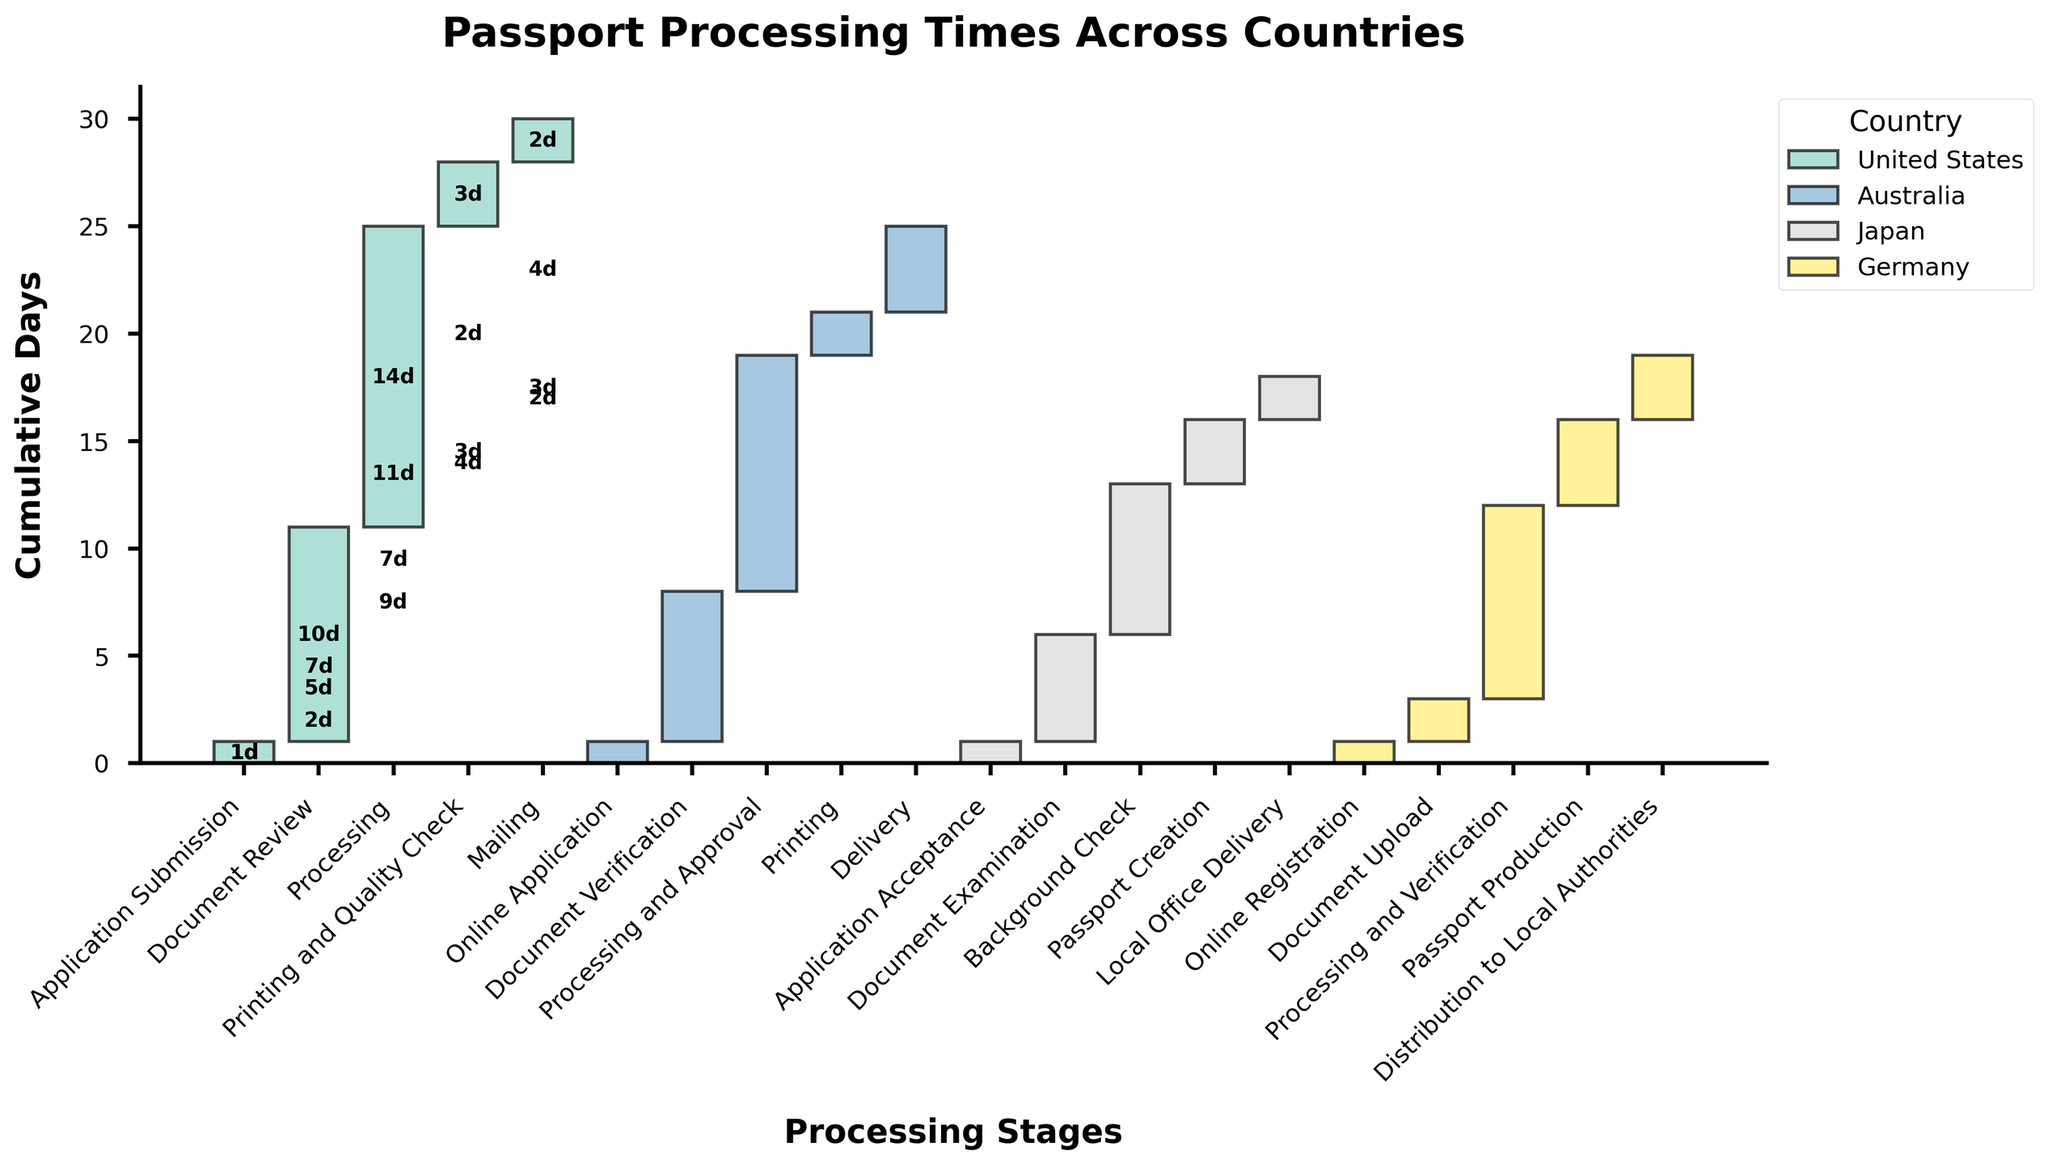What's the title of the figure? The title is located at the top of the figure, prominently displayed in larger font.
Answer: Passport Processing Times Across Countries Which country has the shortest application stage? By observing the length of the first bar for each country, we can see that the application stages all take 1 day for every country.
Answer: United States, Australia, Japan, Germany How many stages are there in the passport processing of the United States? Counting the bars in the United States section on the x-axis, we see there are 5 stages.
Answer: 5 What is the longest stage for Japan? The longest stage is indicated by the largest bar. For Japan, the 'Background Check' stage has the longest bar at 7 days.
Answer: Background Check Which country has the longest total passport processing time? Summing up the days for each stage for all countries, the United States has a total of 30 days, while Australia has 25 days, Japan 18 days, and Germany 19 days. The highest sum is for the United States.
Answer: United States How many days does the 'Processing and Verification' stage take in Germany? By finding the 'Processing and Verification' stage for Germany, we see it takes 9 days.
Answer: 9 days What is the cumulative time to reach the 'Printing' stage in Australia? Adding the days for stages leading up to and including 'Printing' in Australia: 1 (Online Application) + 7 (Document Verification) + 11 (Processing and Approval) + 2 (Printing) = 21 days.
Answer: 21 days Compare the 'Document Review' stage of the United States with the 'Document Verification' stage of Australia.Which is longer, and by how many days? The 'Document Review' in the United States takes 10 days, while 'Document Verification' in Australia takes 7 days. The 'Document Review' stage is longer by 3 days.
Answer: United States by 3 days Identify the stage in Germany that takes the least amount of time. By finding the shortest bar in Germany's stages, the 'Document Upload' stage takes the least time at 2 days.
Answer: Document Upload What is the difference in processing time from submission to completion between the United States and Japan? Calculating the total days for the United States: 1 + 10 + 14 + 3 + 2 = 30 days. Calculating the total days for Japan: 1 + 5 + 7 + 3 + 2 = 18 days. The difference is 30 - 18 = 12 days.
Answer: 12 days 